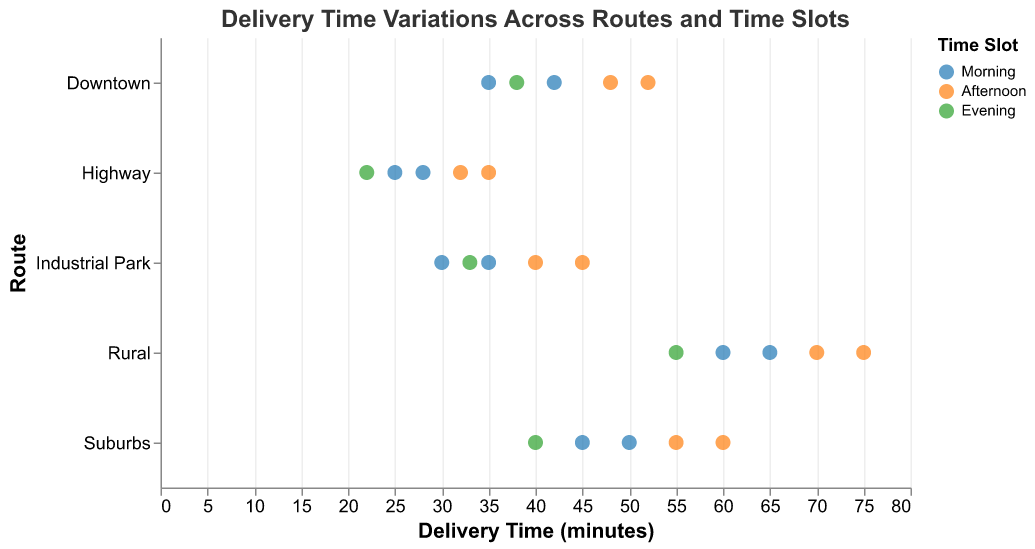What is the title of the graph? The title of the graph is displayed at the top and reads "Delivery Time Variations Across Routes and Time Slots".
Answer: Delivery Time Variations Across Routes and Time Slots How many routes are represented in the plot? The y-axis lists the routes, and they are Downtown, Suburbs, Industrial Park, Highway, and Rural. Counting these, we find 5 routes.
Answer: 5 Which route has the longest delivery time and at what time slot does it occur? Looking at the highest delivery times on the x-axis, we see the point at 75 minutes, which corresponds to the "Rural" route during the "Afternoon" time slot.
Answer: Rural, Afternoon Compare the delivery times for the "Highway" route during the "Morning" and "Evening" time slots. Which slot has faster deliveries? For the "Highway" route, the delivery times during the "Morning" are 25 and 28 minutes, while in the "Evening" it is 22 minutes. The "Evening" slot has faster deliveries.
Answer: Evening What is the range of delivery times for the "Suburbs" route in the "Afternoon"? The delivery times for the "Suburbs" route in the "Afternoon" are 55 and 60 minutes. The range is calculated as the difference between the maximum and minimum delivery times: 60 - 55 = 5 minutes.
Answer: 5 minutes Which route has the smallest variation in delivery times across all time slots? The "Highway" route has delivery times ranging from 22 minutes to 35 minutes. This is a 13-minute range, smaller than the ranges for other routes (Downtown: 35-52 = 17, Suburbs: 45-60 = 15, Industrial Park: 30-45 = 15, Rural: 55-75 = 20). Thus, the "Highway" route has the smallest variation.
Answer: Highway How do the delivery times for "Industrial Park" in the "Morning" compare to those in the "Afternoon"? In the "Morning," the delivery times for "Industrial Park" are 30 and 35 minutes. In the "Afternoon," they are 40 and 45 minutes. Delivery times in the "Morning" are consistently lower.
Answer: Morning What is the average delivery time for the "Downtown" route across all time slots? The delivery times for "Downtown" are 35, 42, 48, 52, and 38 minutes. Summing these gives 35 + 42 + 48 + 52 + 38 = 215. Dividing by 5, the average is 215/5 = 43 minutes.
Answer: 43 minutes Which time slot generally shows the highest delivery times? By looking at the colors representing time slots on the plot, we see that the "Afternoon" time slot often has the highest delivery times across different routes, e.g., 75 minutes for Rural, 60 minutes for Suburbs.
Answer: Afternoon 